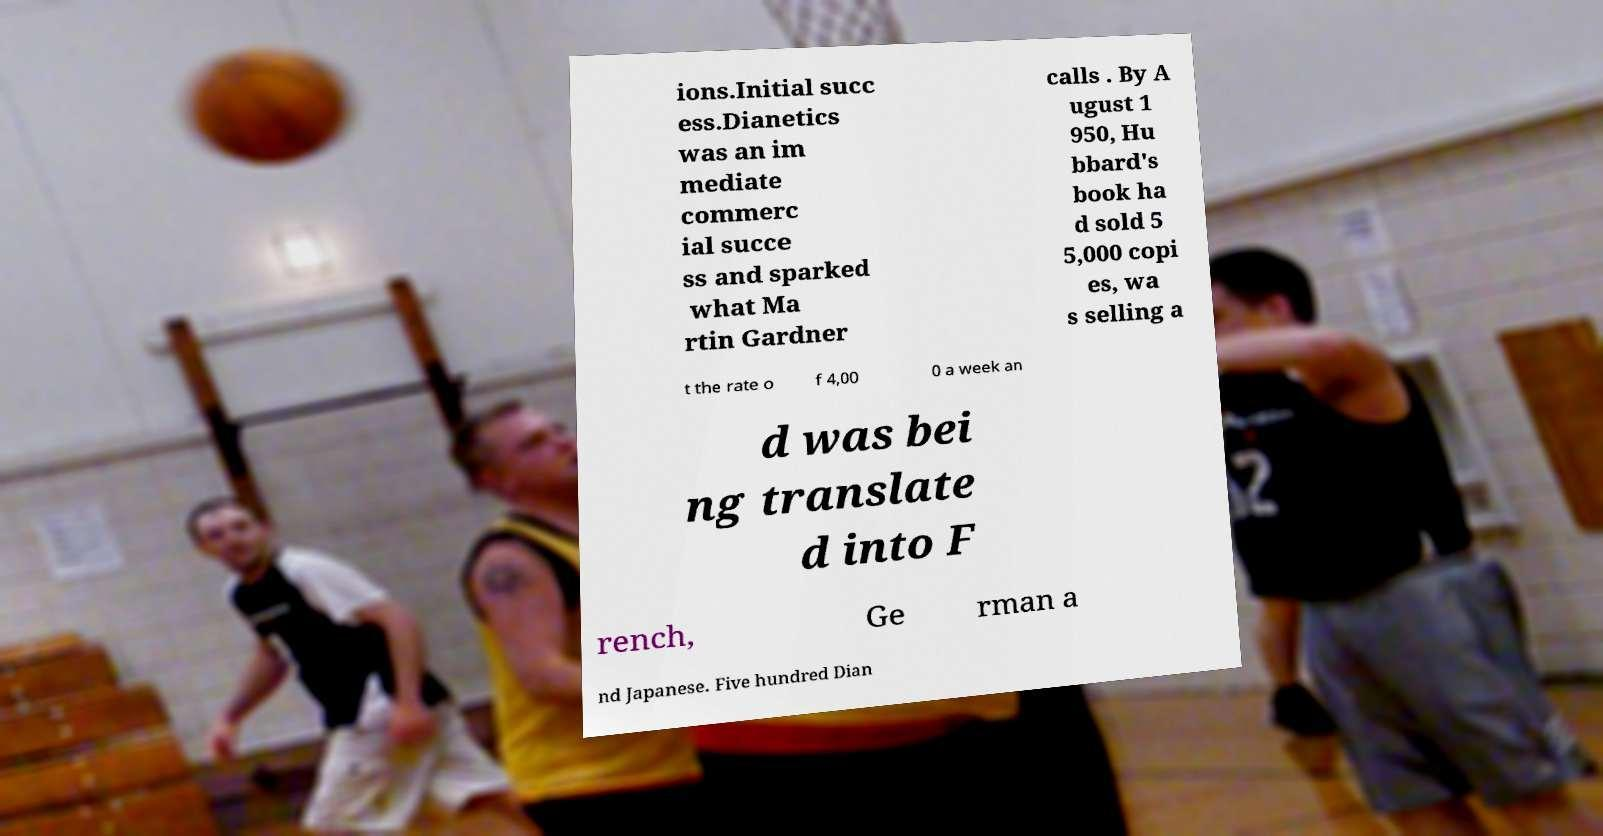Can you accurately transcribe the text from the provided image for me? ions.Initial succ ess.Dianetics was an im mediate commerc ial succe ss and sparked what Ma rtin Gardner calls . By A ugust 1 950, Hu bbard's book ha d sold 5 5,000 copi es, wa s selling a t the rate o f 4,00 0 a week an d was bei ng translate d into F rench, Ge rman a nd Japanese. Five hundred Dian 